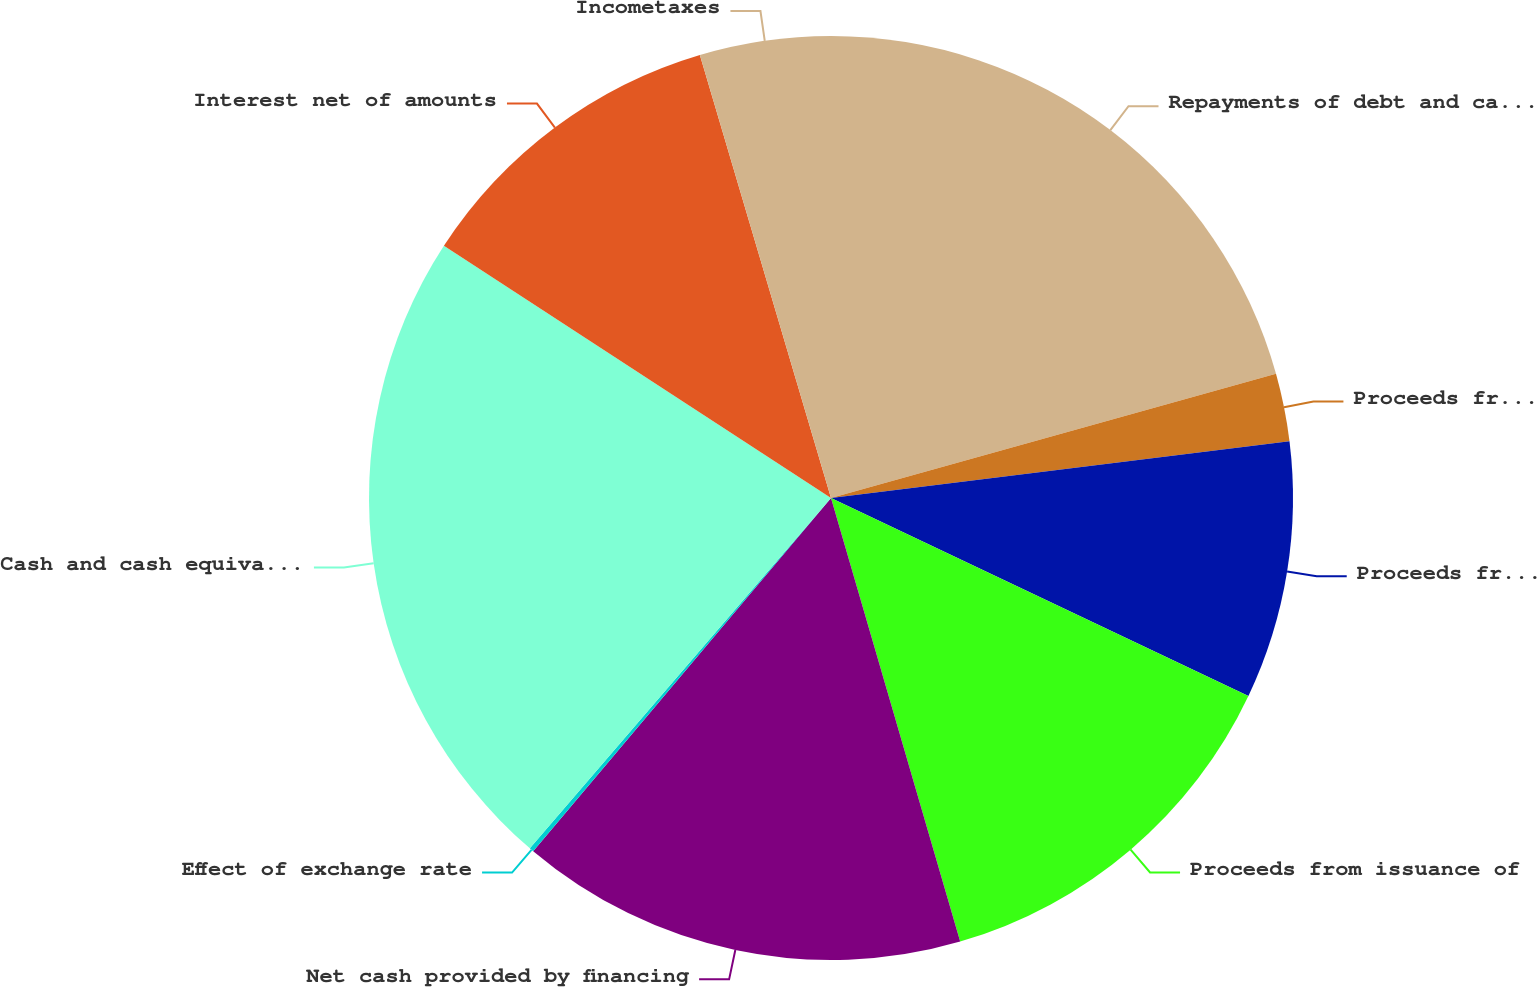Convert chart. <chart><loc_0><loc_0><loc_500><loc_500><pie_chart><fcel>Repayments of debt and capital<fcel>Proceeds from foreign grants<fcel>Proceeds from sale leaseback<fcel>Proceeds from issuance of<fcel>Net cash provided by financing<fcel>Effect of exchange rate<fcel>Cash and cash equivalents at<fcel>Interest net of amounts<fcel>Incometaxes<nl><fcel>20.67%<fcel>2.37%<fcel>9.01%<fcel>13.44%<fcel>15.66%<fcel>0.15%<fcel>22.89%<fcel>11.23%<fcel>4.58%<nl></chart> 